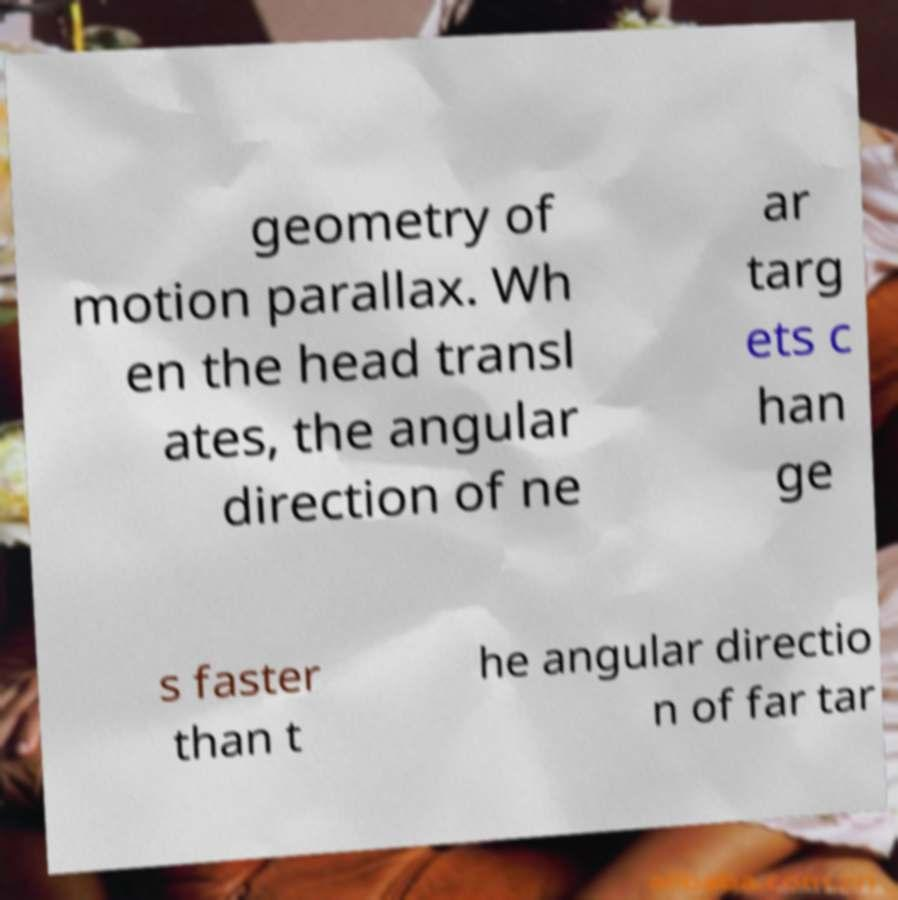There's text embedded in this image that I need extracted. Can you transcribe it verbatim? geometry of motion parallax. Wh en the head transl ates, the angular direction of ne ar targ ets c han ge s faster than t he angular directio n of far tar 